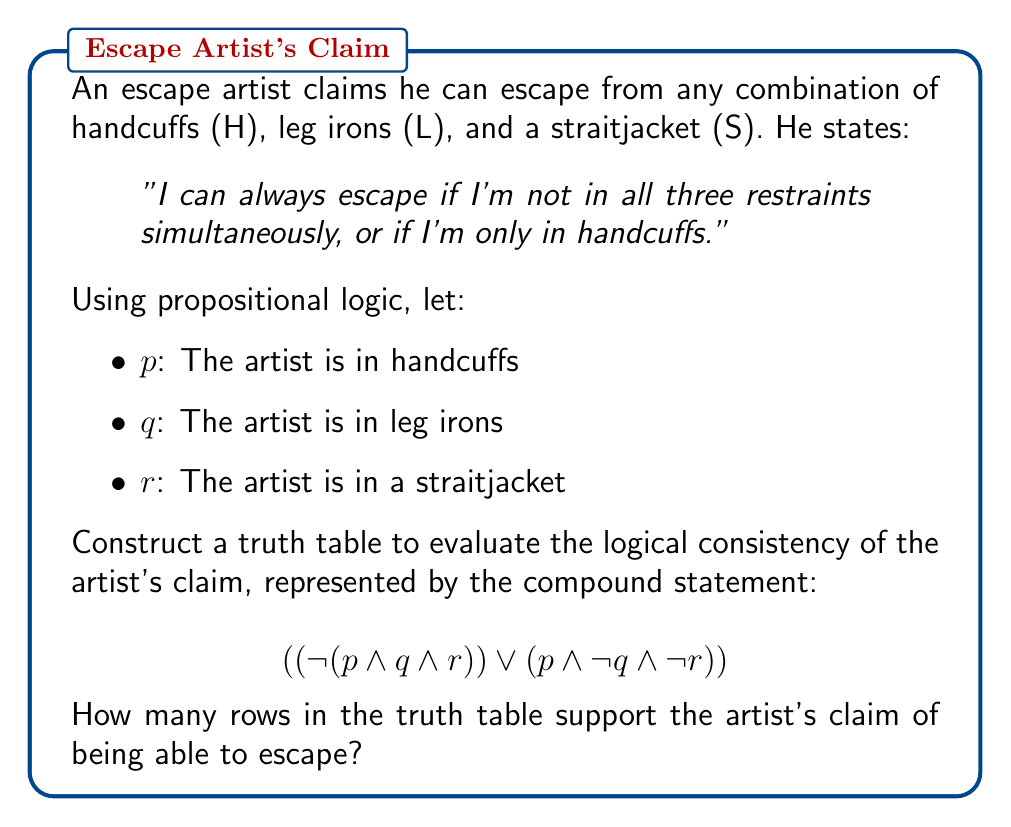Show me your answer to this math problem. To evaluate the logical consistency of the escape artist's claim, we need to construct a truth table for the given compound statement. Let's break it down step-by-step:

1. First, we'll create a truth table with columns for p, q, and r.

2. Next, we'll add columns for the subexpressions:
   a. $(p \land q \land r)$
   b. $\neg (p \land q \land r)$
   c. $(p \land \neg q \land \neg r)$

3. Finally, we'll add a column for the entire expression:
   $$((\neg (p \land q \land r)) \lor (p \land \neg q \land \neg r))$$

Here's the complete truth table:

| p | q | r | $(p \land q \land r)$ | $\neg (p \land q \land r)$ | $(p \land \neg q \land \neg r)$ | Final Result |
|---|---|---|------------------------|----------------------------|--------------------------------|--------------|
| T | T | T | T                      | F                          | F                              | F            |
| T | T | F | F                      | T                          | F                              | T            |
| T | F | T | F                      | T                          | F                              | T            |
| T | F | F | F                      | T                          | T                              | T            |
| F | T | T | F                      | T                          | F                              | T            |
| F | T | F | F                      | T                          | F                              | T            |
| F | F | T | F                      | T                          | F                              | T            |
| F | F | F | F                      | T                          | F                              | T            |

4. Interpreting the results:
   - The final column represents when the artist claims he can escape.
   - A 'T' in this column means the artist claims he can escape in that scenario.
   - An 'F' means he cannot escape.

5. Counting the number of 'T's in the final column:
   There are 7 rows where the final result is 'T'.

Therefore, there are 7 rows in the truth table that support the artist's claim of being able to escape.
Answer: 7 rows 